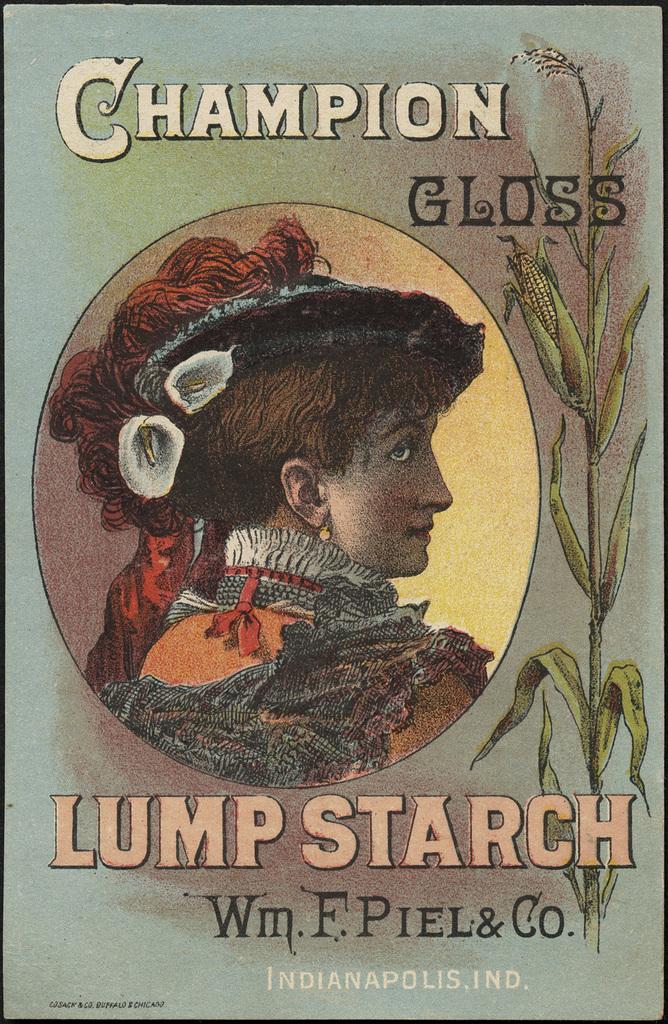What city name is mentioned at the bottom?
Ensure brevity in your answer.  Indianapolis. What is this?
Keep it short and to the point. Lump starch. 